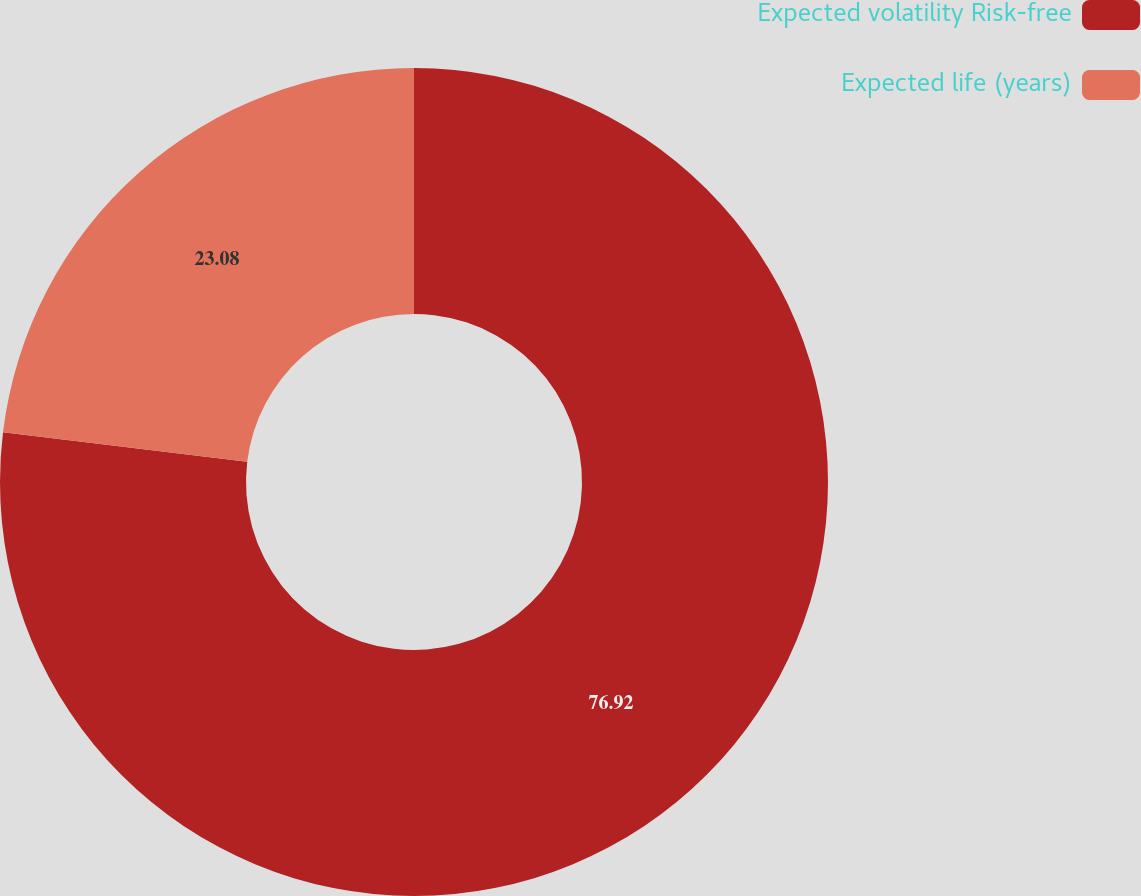Convert chart to OTSL. <chart><loc_0><loc_0><loc_500><loc_500><pie_chart><fcel>Expected volatility Risk-free<fcel>Expected life (years)<nl><fcel>76.92%<fcel>23.08%<nl></chart> 